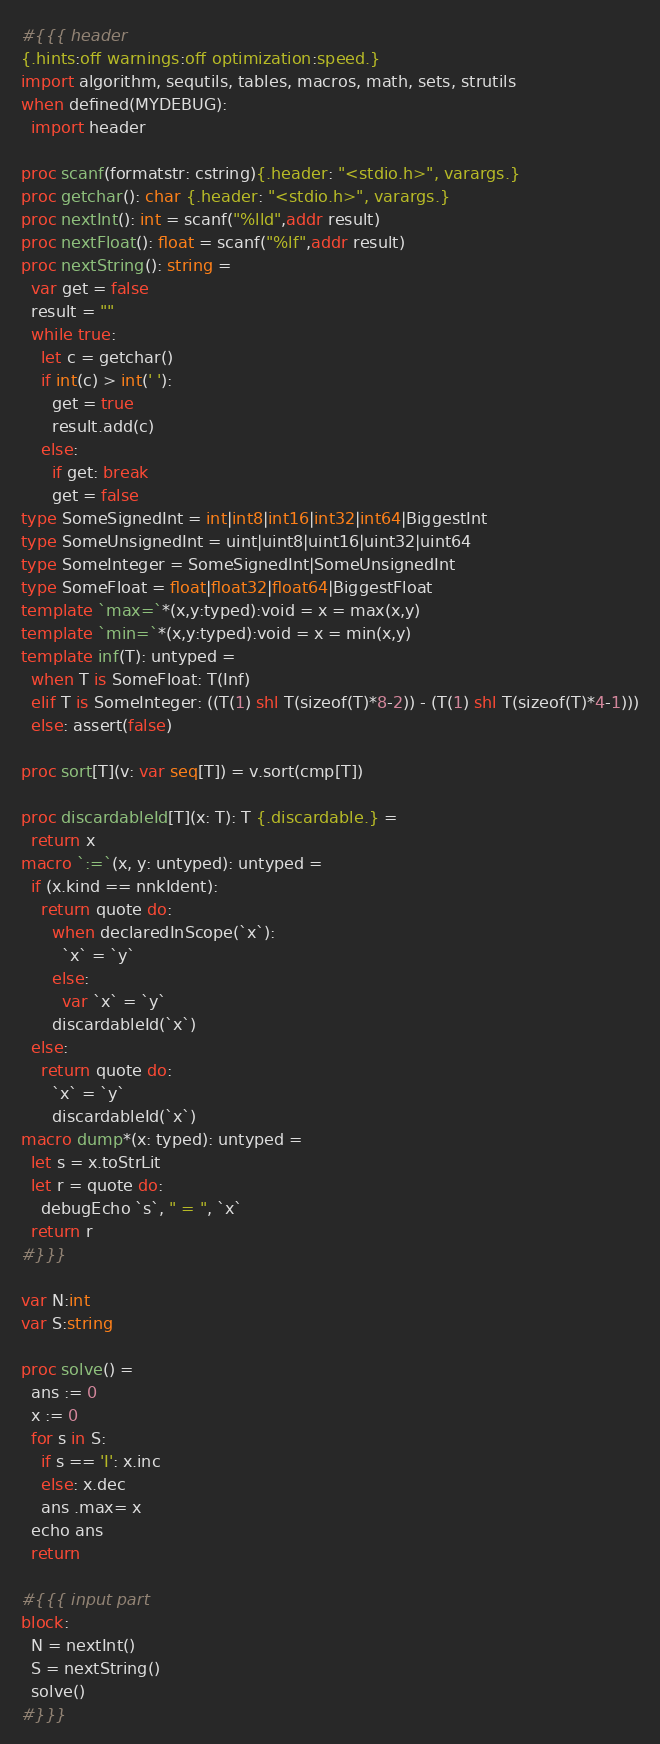<code> <loc_0><loc_0><loc_500><loc_500><_Nim_>#{{{ header
{.hints:off warnings:off optimization:speed.}
import algorithm, sequtils, tables, macros, math, sets, strutils
when defined(MYDEBUG):
  import header

proc scanf(formatstr: cstring){.header: "<stdio.h>", varargs.}
proc getchar(): char {.header: "<stdio.h>", varargs.}
proc nextInt(): int = scanf("%lld",addr result)
proc nextFloat(): float = scanf("%lf",addr result)
proc nextString(): string =
  var get = false
  result = ""
  while true:
    let c = getchar()
    if int(c) > int(' '):
      get = true
      result.add(c)
    else:
      if get: break
      get = false
type SomeSignedInt = int|int8|int16|int32|int64|BiggestInt
type SomeUnsignedInt = uint|uint8|uint16|uint32|uint64
type SomeInteger = SomeSignedInt|SomeUnsignedInt
type SomeFloat = float|float32|float64|BiggestFloat
template `max=`*(x,y:typed):void = x = max(x,y)
template `min=`*(x,y:typed):void = x = min(x,y)
template inf(T): untyped = 
  when T is SomeFloat: T(Inf)
  elif T is SomeInteger: ((T(1) shl T(sizeof(T)*8-2)) - (T(1) shl T(sizeof(T)*4-1)))
  else: assert(false)

proc sort[T](v: var seq[T]) = v.sort(cmp[T])

proc discardableId[T](x: T): T {.discardable.} =
  return x
macro `:=`(x, y: untyped): untyped =
  if (x.kind == nnkIdent):
    return quote do:
      when declaredInScope(`x`):
        `x` = `y`
      else:
        var `x` = `y`
      discardableId(`x`)
  else:
    return quote do:
      `x` = `y`
      discardableId(`x`)
macro dump*(x: typed): untyped =
  let s = x.toStrLit
  let r = quote do:
    debugEcho `s`, " = ", `x`
  return r
#}}}

var N:int
var S:string

proc solve() =
  ans := 0
  x := 0
  for s in S:
    if s == 'I': x.inc
    else: x.dec
    ans .max= x
  echo ans
  return

#{{{ input part
block:
  N = nextInt()
  S = nextString()
  solve()
#}}}
</code> 